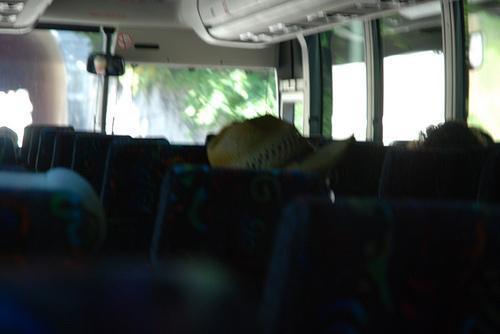How many windows are captured on the right?
Give a very brief answer. 3. 